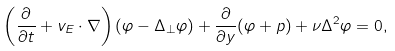<formula> <loc_0><loc_0><loc_500><loc_500>\left ( \frac { \partial } { \partial t } + v _ { E } \cdot \nabla \right ) ( \varphi - \Delta _ { \perp } \varphi ) + \frac { \partial } { \partial y } ( \varphi + p ) + \nu \Delta ^ { 2 } \varphi = 0 ,</formula> 